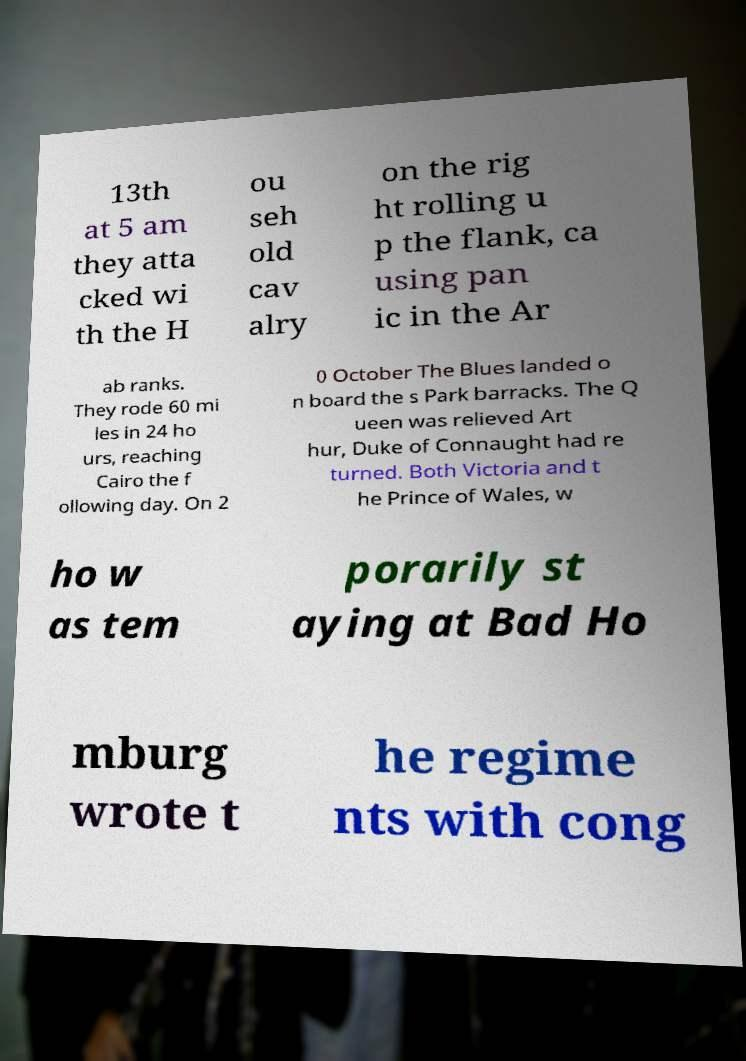Could you extract and type out the text from this image? 13th at 5 am they atta cked wi th the H ou seh old cav alry on the rig ht rolling u p the flank, ca using pan ic in the Ar ab ranks. They rode 60 mi les in 24 ho urs, reaching Cairo the f ollowing day. On 2 0 October The Blues landed o n board the s Park barracks. The Q ueen was relieved Art hur, Duke of Connaught had re turned. Both Victoria and t he Prince of Wales, w ho w as tem porarily st aying at Bad Ho mburg wrote t he regime nts with cong 